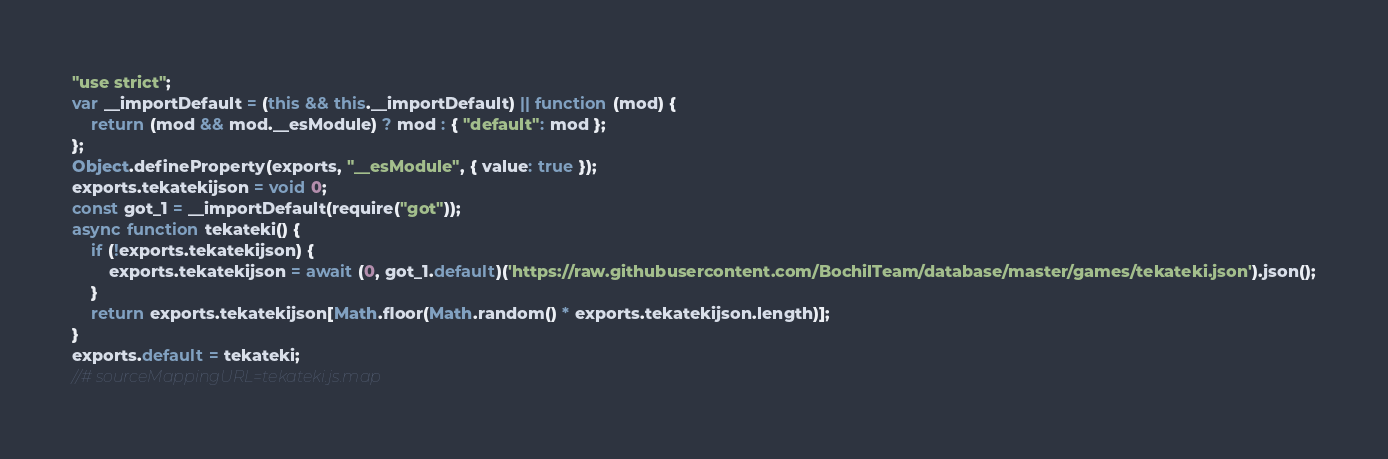Convert code to text. <code><loc_0><loc_0><loc_500><loc_500><_JavaScript_>"use strict";
var __importDefault = (this && this.__importDefault) || function (mod) {
    return (mod && mod.__esModule) ? mod : { "default": mod };
};
Object.defineProperty(exports, "__esModule", { value: true });
exports.tekatekijson = void 0;
const got_1 = __importDefault(require("got"));
async function tekateki() {
    if (!exports.tekatekijson) {
        exports.tekatekijson = await (0, got_1.default)('https://raw.githubusercontent.com/BochilTeam/database/master/games/tekateki.json').json();
    }
    return exports.tekatekijson[Math.floor(Math.random() * exports.tekatekijson.length)];
}
exports.default = tekateki;
//# sourceMappingURL=tekateki.js.map</code> 